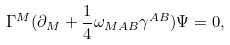<formula> <loc_0><loc_0><loc_500><loc_500>\Gamma ^ { M } ( \partial _ { M } + \frac { 1 } { 4 } \omega _ { M A B } \gamma ^ { A B } ) \Psi = 0 ,</formula> 